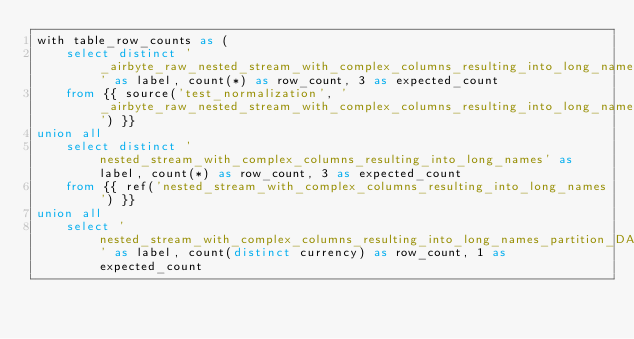<code> <loc_0><loc_0><loc_500><loc_500><_SQL_>with table_row_counts as (
    select distinct '_airbyte_raw_nested_stream_with_complex_columns_resulting_into_long_names' as label, count(*) as row_count, 3 as expected_count
    from {{ source('test_normalization', '_airbyte_raw_nested_stream_with_complex_columns_resulting_into_long_names') }}
union all
    select distinct 'nested_stream_with_complex_columns_resulting_into_long_names' as label, count(*) as row_count, 3 as expected_count
    from {{ ref('nested_stream_with_complex_columns_resulting_into_long_names') }}
union all
    select 'nested_stream_with_complex_columns_resulting_into_long_names_partition_DATA' as label, count(distinct currency) as row_count, 1 as expected_count</code> 